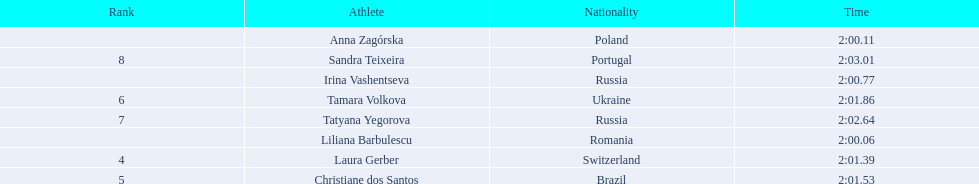Who were the athletes? Liliana Barbulescu, 2:00.06, Anna Zagórska, 2:00.11, Irina Vashentseva, 2:00.77, Laura Gerber, 2:01.39, Christiane dos Santos, 2:01.53, Tamara Volkova, 2:01.86, Tatyana Yegorova, 2:02.64, Sandra Teixeira, 2:03.01. Who received 2nd place? Anna Zagórska, 2:00.11. What was her time? 2:00.11. 